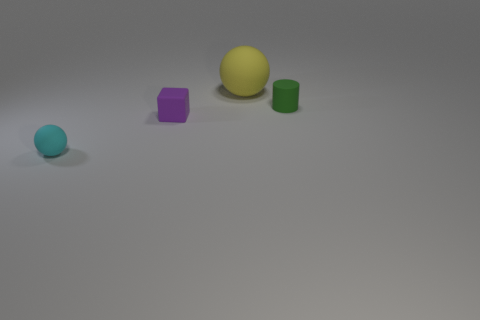Add 1 cylinders. How many objects exist? 5 Subtract all cylinders. How many objects are left? 3 Subtract all cyan things. Subtract all yellow rubber things. How many objects are left? 2 Add 3 yellow spheres. How many yellow spheres are left? 4 Add 4 tiny things. How many tiny things exist? 7 Subtract 1 cyan spheres. How many objects are left? 3 